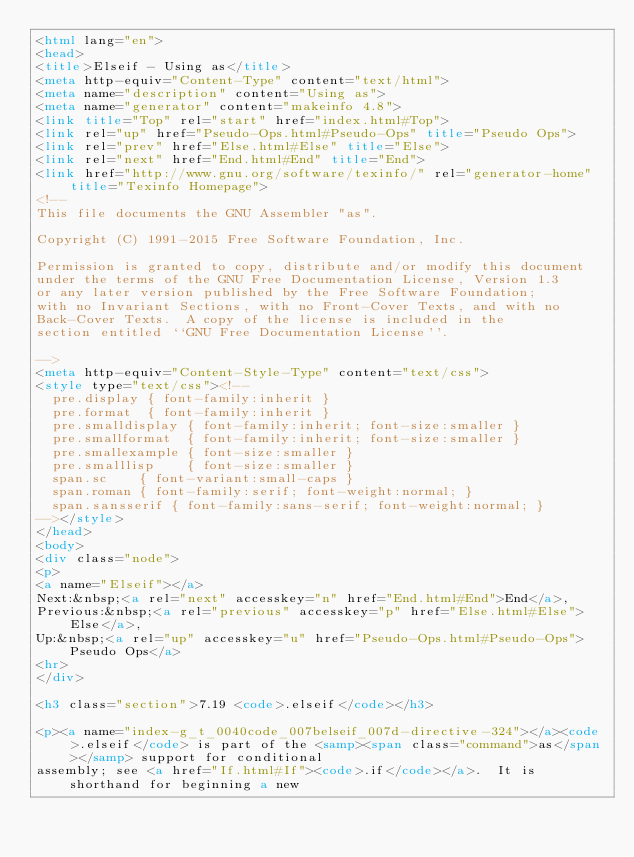<code> <loc_0><loc_0><loc_500><loc_500><_HTML_><html lang="en">
<head>
<title>Elseif - Using as</title>
<meta http-equiv="Content-Type" content="text/html">
<meta name="description" content="Using as">
<meta name="generator" content="makeinfo 4.8">
<link title="Top" rel="start" href="index.html#Top">
<link rel="up" href="Pseudo-Ops.html#Pseudo-Ops" title="Pseudo Ops">
<link rel="prev" href="Else.html#Else" title="Else">
<link rel="next" href="End.html#End" title="End">
<link href="http://www.gnu.org/software/texinfo/" rel="generator-home" title="Texinfo Homepage">
<!--
This file documents the GNU Assembler "as".

Copyright (C) 1991-2015 Free Software Foundation, Inc.

Permission is granted to copy, distribute and/or modify this document
under the terms of the GNU Free Documentation License, Version 1.3
or any later version published by the Free Software Foundation;
with no Invariant Sections, with no Front-Cover Texts, and with no
Back-Cover Texts.  A copy of the license is included in the
section entitled ``GNU Free Documentation License''.

-->
<meta http-equiv="Content-Style-Type" content="text/css">
<style type="text/css"><!--
  pre.display { font-family:inherit }
  pre.format  { font-family:inherit }
  pre.smalldisplay { font-family:inherit; font-size:smaller }
  pre.smallformat  { font-family:inherit; font-size:smaller }
  pre.smallexample { font-size:smaller }
  pre.smalllisp    { font-size:smaller }
  span.sc    { font-variant:small-caps }
  span.roman { font-family:serif; font-weight:normal; } 
  span.sansserif { font-family:sans-serif; font-weight:normal; } 
--></style>
</head>
<body>
<div class="node">
<p>
<a name="Elseif"></a>
Next:&nbsp;<a rel="next" accesskey="n" href="End.html#End">End</a>,
Previous:&nbsp;<a rel="previous" accesskey="p" href="Else.html#Else">Else</a>,
Up:&nbsp;<a rel="up" accesskey="u" href="Pseudo-Ops.html#Pseudo-Ops">Pseudo Ops</a>
<hr>
</div>

<h3 class="section">7.19 <code>.elseif</code></h3>

<p><a name="index-g_t_0040code_007belseif_007d-directive-324"></a><code>.elseif</code> is part of the <samp><span class="command">as</span></samp> support for conditional
assembly; see <a href="If.html#If"><code>.if</code></a>.  It is shorthand for beginning a new</code> 